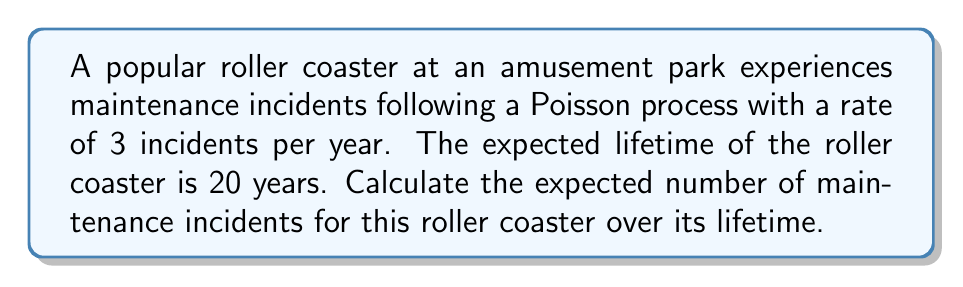Give your solution to this math problem. Let's approach this step-by-step:

1) We are dealing with a Poisson process, which is a type of stochastic process used to model random events that occur at a constant average rate.

2) The key properties of a Poisson process that we'll use are:
   - The number of events in any interval follows a Poisson distribution
   - The expected number of events in an interval is proportional to the length of the interval

3) Given:
   - Rate of incidents: $\lambda = 3$ incidents per year
   - Lifetime of the roller coaster: $T = 20$ years

4) For a Poisson process, the expected number of events $E[N(t)]$ in a time interval $t$ is given by:

   $$E[N(t)] = \lambda t$$

5) In our case, we want to find $E[N(T)]$ where $T = 20$ years:

   $$E[N(T)] = \lambda T = 3 \times 20 = 60$$

Therefore, the expected number of maintenance incidents over the roller coaster's lifetime is 60.
Answer: 60 incidents 